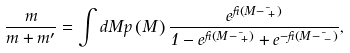<formula> <loc_0><loc_0><loc_500><loc_500>\frac { m } { m + m ^ { \prime } } = \int d M p \left ( M \right ) \frac { e ^ { \beta \left ( M - \mu _ { + } \right ) } } { 1 - e ^ { \beta \left ( M - \mu _ { + } \right ) } + e ^ { - \beta \left ( M - \mu _ { - } \right ) } } ,</formula> 